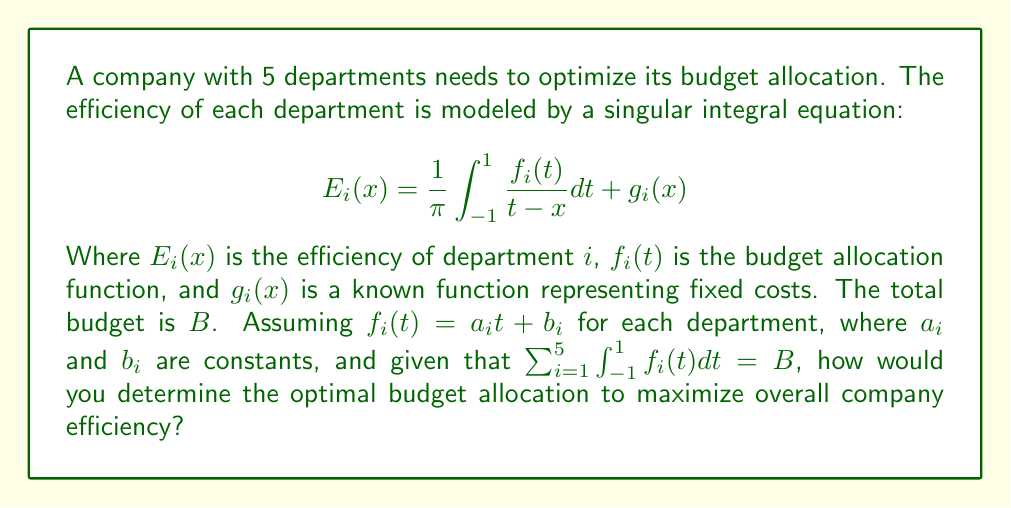Can you answer this question? To solve this problem, we need to follow these steps:

1) First, we need to solve the singular integral equation for each department. The solution to this type of equation is given by:

   $$f_i(x) = \frac{1}{\pi} \int_{-1}^{1} \frac{\sqrt{1-t^2}}{t-x} [E_i(t) - g_i(t)] dt$$

2) Since we're given that $f_i(t) = a_it + b_i$, we can equate this to the solution above:

   $$a_ix + b_i = \frac{1}{\pi} \int_{-1}^{1} \frac{\sqrt{1-t^2}}{t-x} [E_i(t) - g_i(t)] dt$$

3) This equation must hold for all $x$. We can use this to determine $a_i$ and $b_i$ in terms of $E_i(t)$ and $g_i(t)$.

4) The constraint $\sum_{i=1}^{5} \int_{-1}^{1} f_i(t) dt = B$ can be written as:

   $$\sum_{i=1}^{5} \int_{-1}^{1} (a_it + b_i) dt = B$$

   Which simplifies to:

   $$\sum_{i=1}^{5} 2b_i = B$$

5) The overall company efficiency can be expressed as:

   $$E_{total} = \sum_{i=1}^{5} \int_{-1}^{1} E_i(x) dx$$

6) Our goal is to maximize $E_{total}$ subject to the constraint in step 4.

7) This becomes an optimization problem that can be solved using the method of Lagrange multipliers:

   $$L = \sum_{i=1}^{5} \int_{-1}^{1} E_i(x) dx - \lambda(\sum_{i=1}^{5} 2b_i - B)$$

8) We would then need to solve the system of equations:

   $$\frac{\partial L}{\partial a_i} = 0, \frac{\partial L}{\partial b_i} = 0, \frac{\partial L}{\partial \lambda} = 0$$

9) The solution to this system would give us the optimal values for $a_i$ and $b_i$, which determine the optimal budget allocation function $f_i(t)$ for each department.
Answer: Solve singular integral equations, express $f_i(t)$ in terms of $E_i(t)$ and $g_i(t)$, maximize $E_{total}$ using Lagrange multipliers subject to budget constraint. 